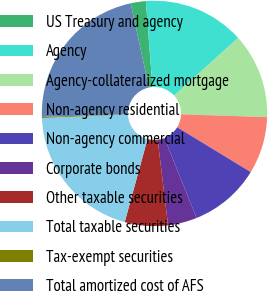Convert chart to OTSL. <chart><loc_0><loc_0><loc_500><loc_500><pie_chart><fcel>US Treasury and agency<fcel>Agency<fcel>Agency-collateralized mortgage<fcel>Non-agency residential<fcel>Non-agency commercial<fcel>Corporate bonds<fcel>Other taxable securities<fcel>Total taxable securities<fcel>Tax-exempt securities<fcel>Total amortized cost of AFS<nl><fcel>2.16%<fcel>14.54%<fcel>12.21%<fcel>8.19%<fcel>10.2%<fcel>4.17%<fcel>6.18%<fcel>20.1%<fcel>0.15%<fcel>22.11%<nl></chart> 